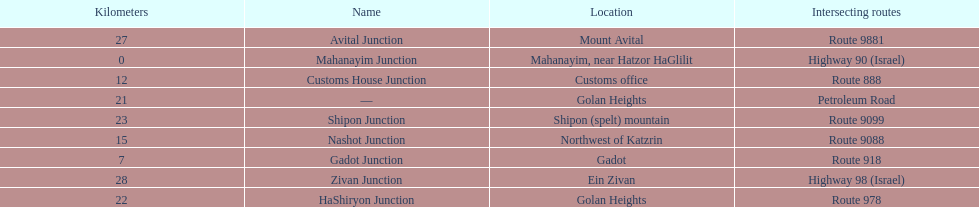What is the number of routes that intersect highway 91? 9. 